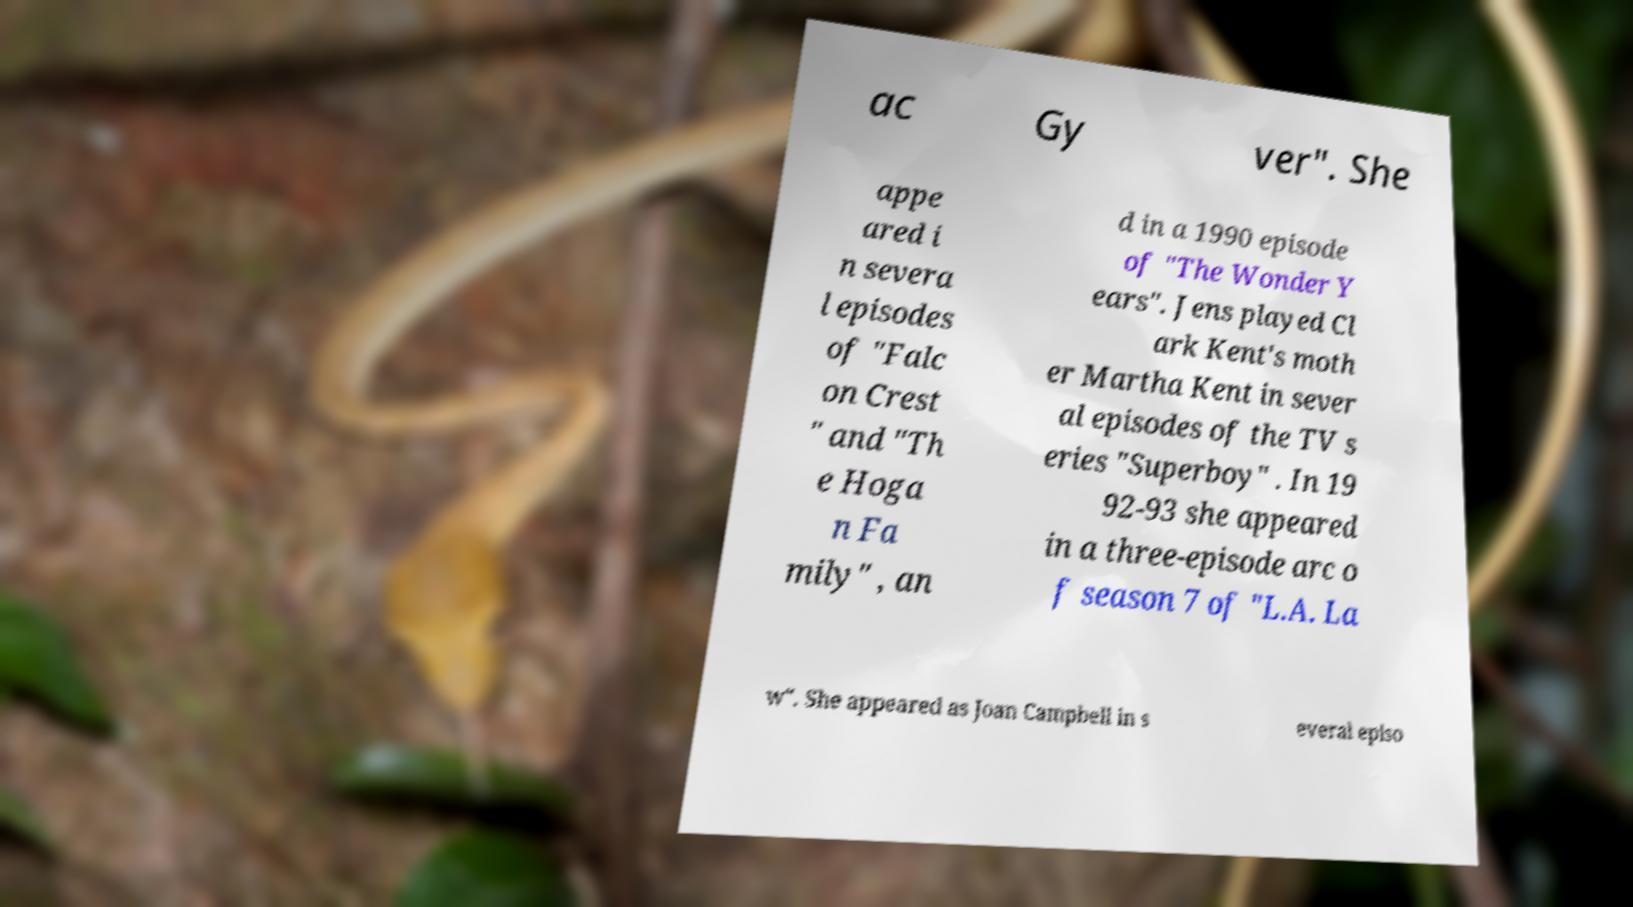What messages or text are displayed in this image? I need them in a readable, typed format. ac Gy ver". She appe ared i n severa l episodes of "Falc on Crest " and "Th e Hoga n Fa mily" , an d in a 1990 episode of "The Wonder Y ears". Jens played Cl ark Kent's moth er Martha Kent in sever al episodes of the TV s eries "Superboy" . In 19 92-93 she appeared in a three-episode arc o f season 7 of "L.A. La w". She appeared as Joan Campbell in s everal episo 